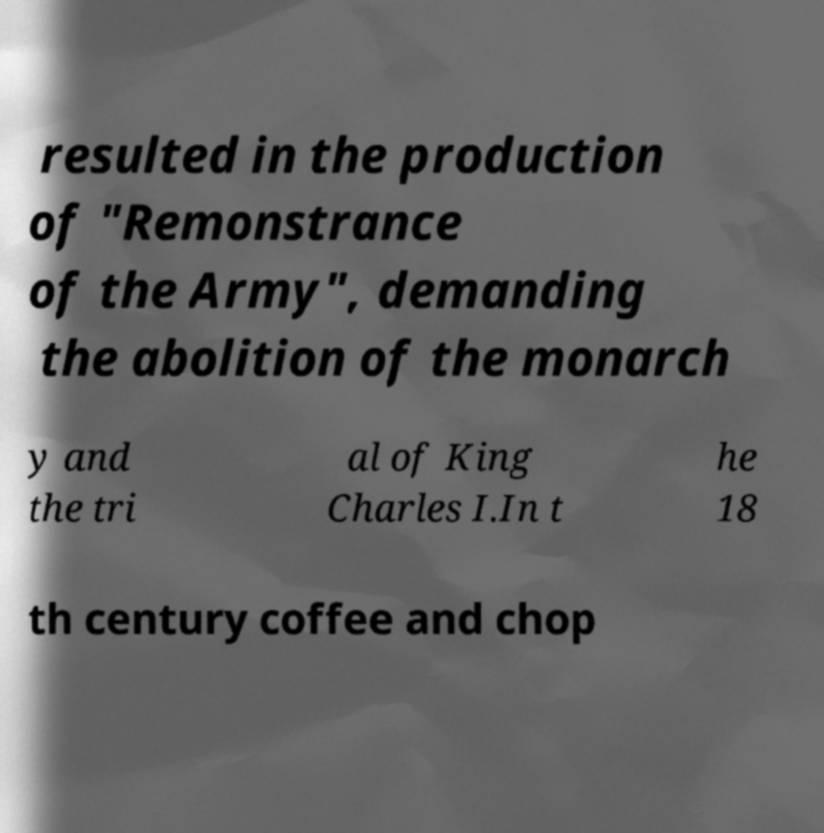For documentation purposes, I need the text within this image transcribed. Could you provide that? resulted in the production of "Remonstrance of the Army", demanding the abolition of the monarch y and the tri al of King Charles I.In t he 18 th century coffee and chop 